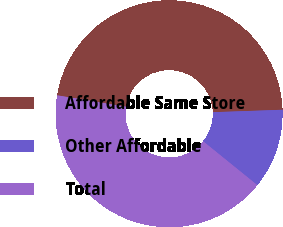Convert chart. <chart><loc_0><loc_0><loc_500><loc_500><pie_chart><fcel>Affordable Same Store<fcel>Other Affordable<fcel>Total<nl><fcel>46.84%<fcel>11.39%<fcel>41.77%<nl></chart> 